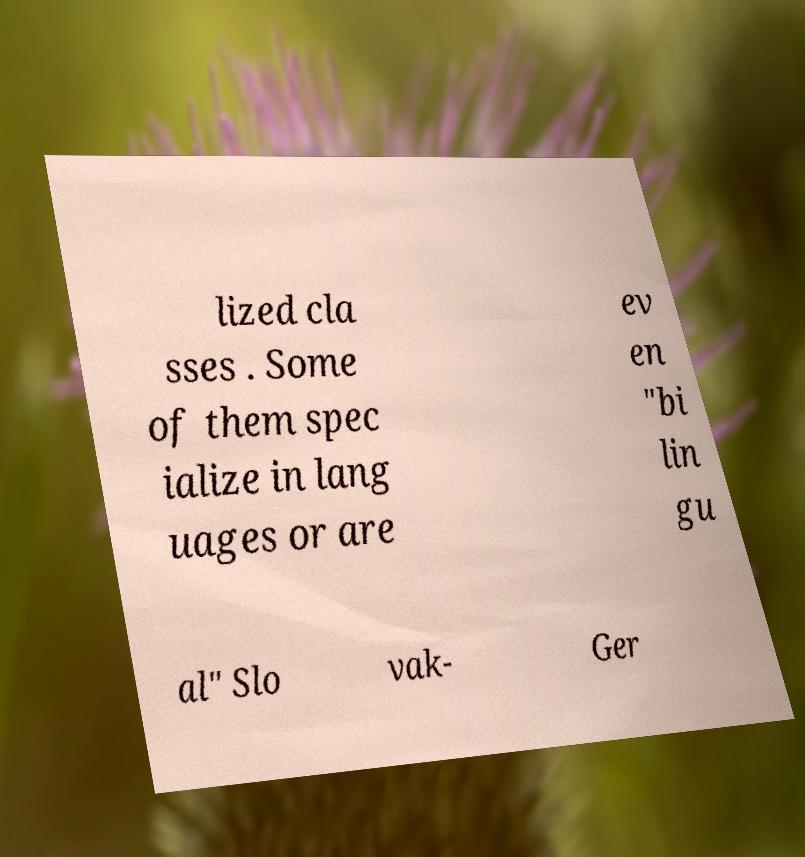Can you accurately transcribe the text from the provided image for me? lized cla sses . Some of them spec ialize in lang uages or are ev en "bi lin gu al" Slo vak- Ger 